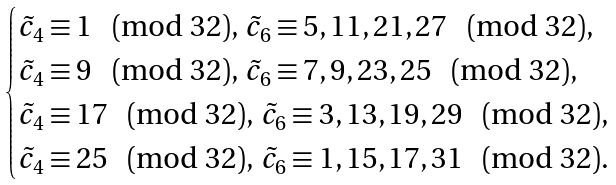<formula> <loc_0><loc_0><loc_500><loc_500>\begin{cases} \tilde { c } _ { 4 } \equiv 1 \pmod { 3 2 } , \, \tilde { c } _ { 6 } \equiv 5 , 1 1 , 2 1 , 2 7 \pmod { 3 2 } , \\ \tilde { c } _ { 4 } \equiv 9 \pmod { 3 2 } , \, \tilde { c } _ { 6 } \equiv 7 , 9 , 2 3 , 2 5 \pmod { 3 2 } , \\ \tilde { c } _ { 4 } \equiv 1 7 \pmod { 3 2 } , \, \tilde { c } _ { 6 } \equiv 3 , 1 3 , 1 9 , 2 9 \pmod { 3 2 } , \\ \tilde { c } _ { 4 } \equiv 2 5 \pmod { 3 2 } , \, \tilde { c } _ { 6 } \equiv 1 , 1 5 , 1 7 , 3 1 \pmod { 3 2 } . \ \end{cases}</formula> 